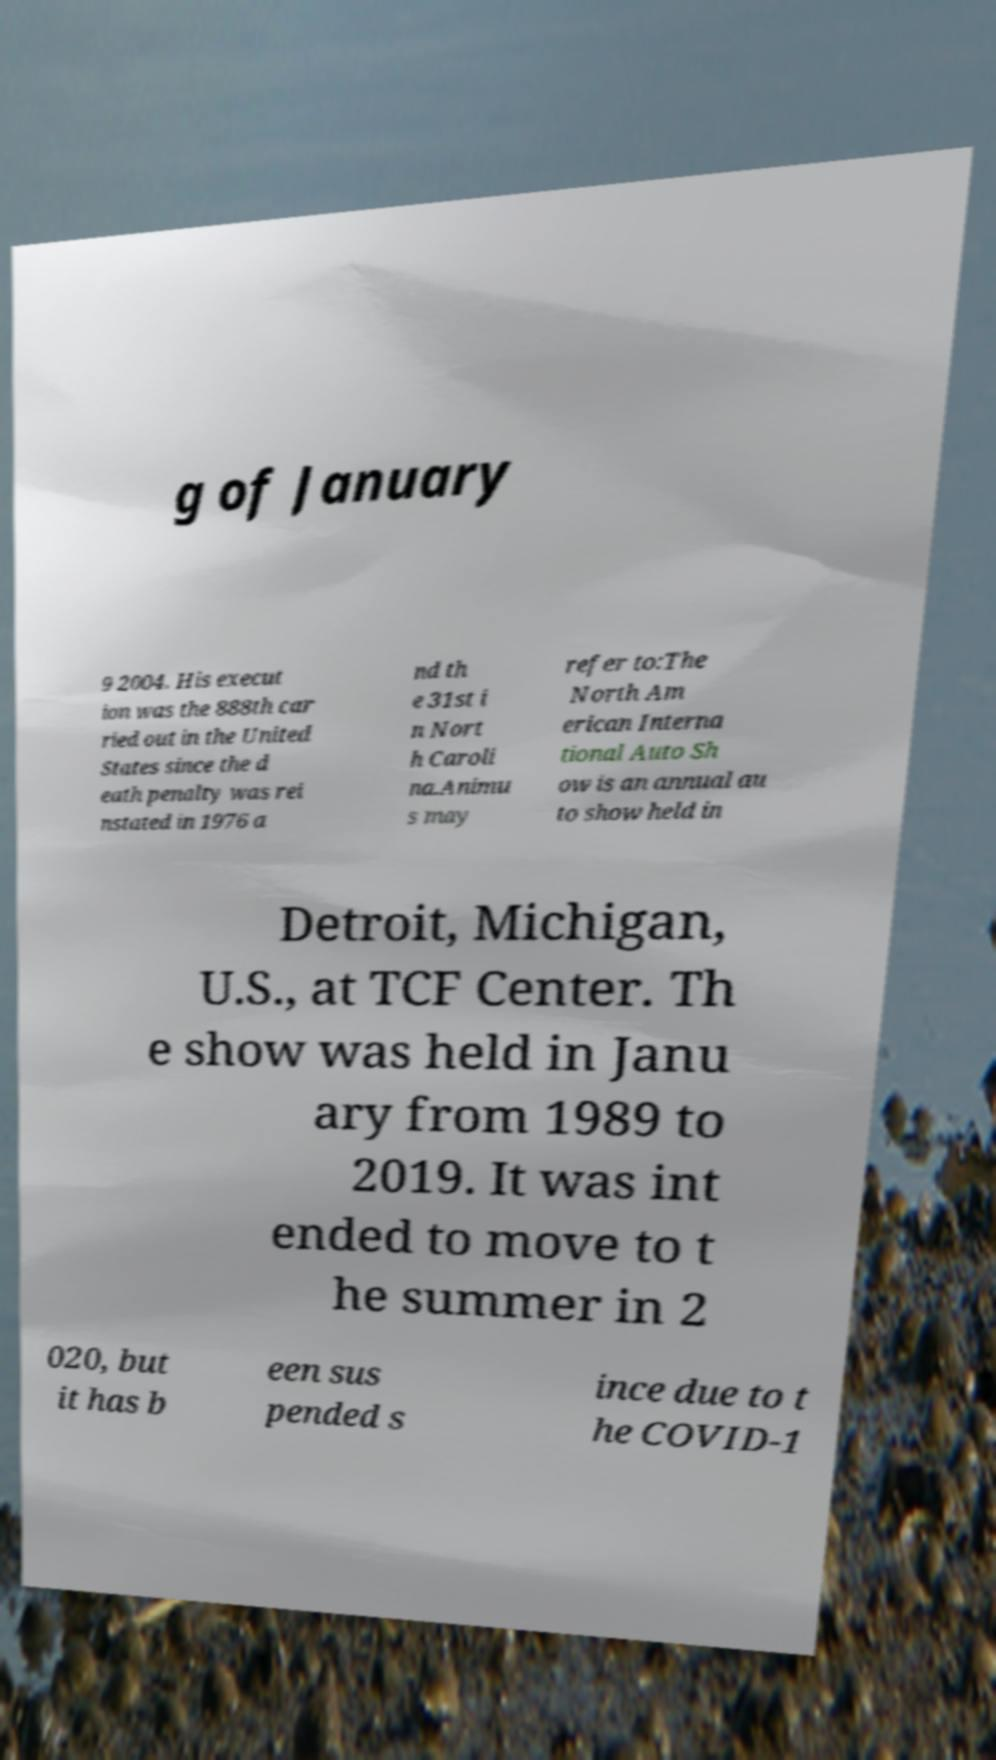Could you extract and type out the text from this image? g of January 9 2004. His execut ion was the 888th car ried out in the United States since the d eath penalty was rei nstated in 1976 a nd th e 31st i n Nort h Caroli na.Animu s may refer to:The North Am erican Interna tional Auto Sh ow is an annual au to show held in Detroit, Michigan, U.S., at TCF Center. Th e show was held in Janu ary from 1989 to 2019. It was int ended to move to t he summer in 2 020, but it has b een sus pended s ince due to t he COVID-1 